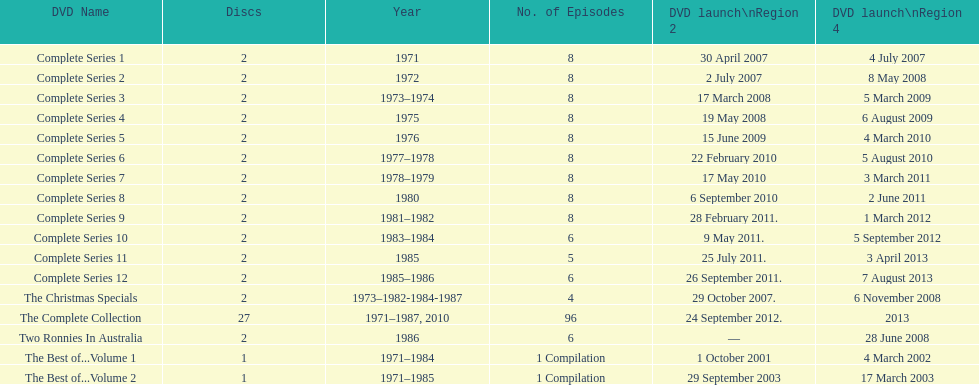What is previous to complete series 10? Complete Series 9. 